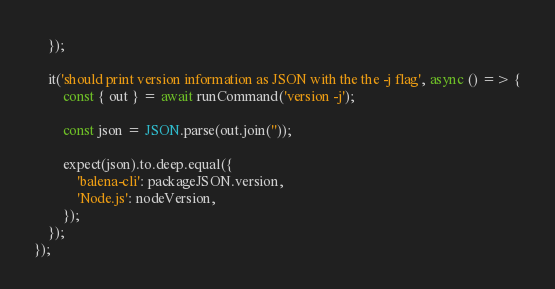Convert code to text. <code><loc_0><loc_0><loc_500><loc_500><_TypeScript_>	});

	it('should print version information as JSON with the the -j flag', async () => {
		const { out } = await runCommand('version -j');

		const json = JSON.parse(out.join(''));

		expect(json).to.deep.equal({
			'balena-cli': packageJSON.version,
			'Node.js': nodeVersion,
		});
	});
});
</code> 